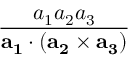<formula> <loc_0><loc_0><loc_500><loc_500>\frac { a _ { 1 } a _ { 2 } a _ { 3 } } { a _ { 1 } \cdot ( a _ { 2 } \times a _ { 3 } ) }</formula> 